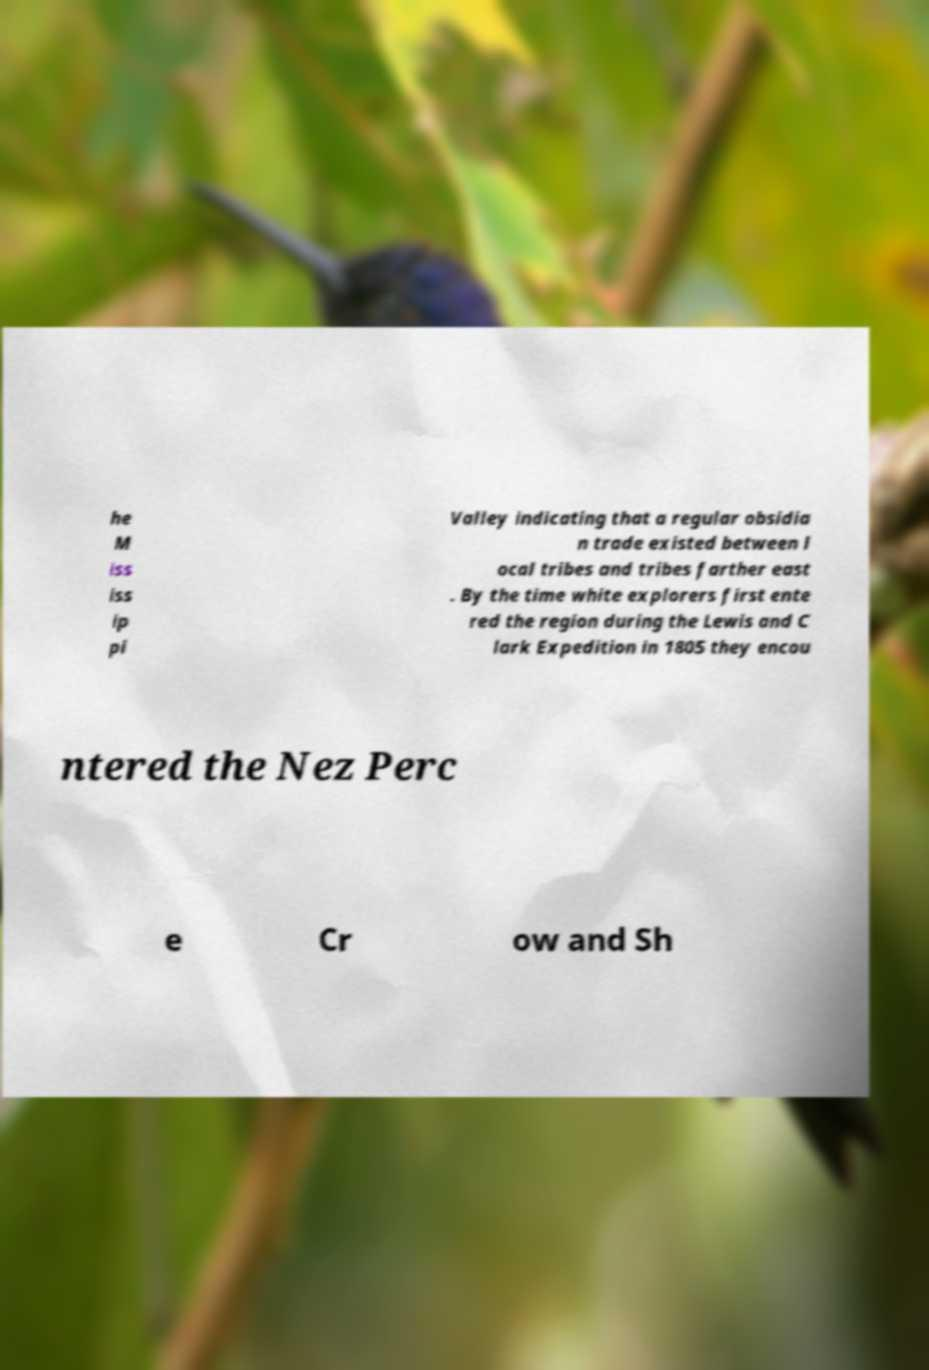Could you assist in decoding the text presented in this image and type it out clearly? he M iss iss ip pi Valley indicating that a regular obsidia n trade existed between l ocal tribes and tribes farther east . By the time white explorers first ente red the region during the Lewis and C lark Expedition in 1805 they encou ntered the Nez Perc e Cr ow and Sh 